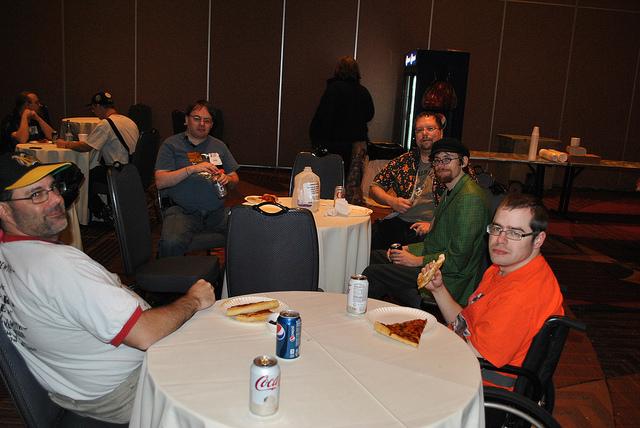Do some of these people have flags?
Keep it brief. No. How many are wearing glasses?
Quick response, please. 4. How many wheelchairs?
Give a very brief answer. 1. What is this person eating?
Give a very brief answer. Pizza. 